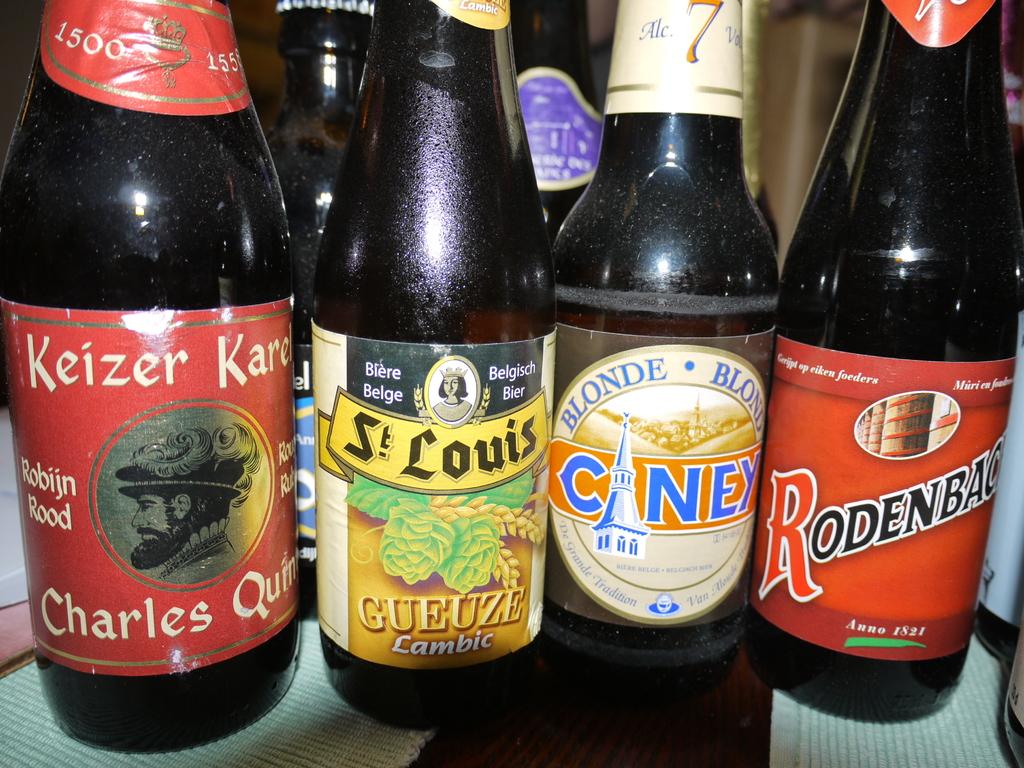How many type of  beer can you see?
Provide a short and direct response. Answering does not require reading text in the image. 